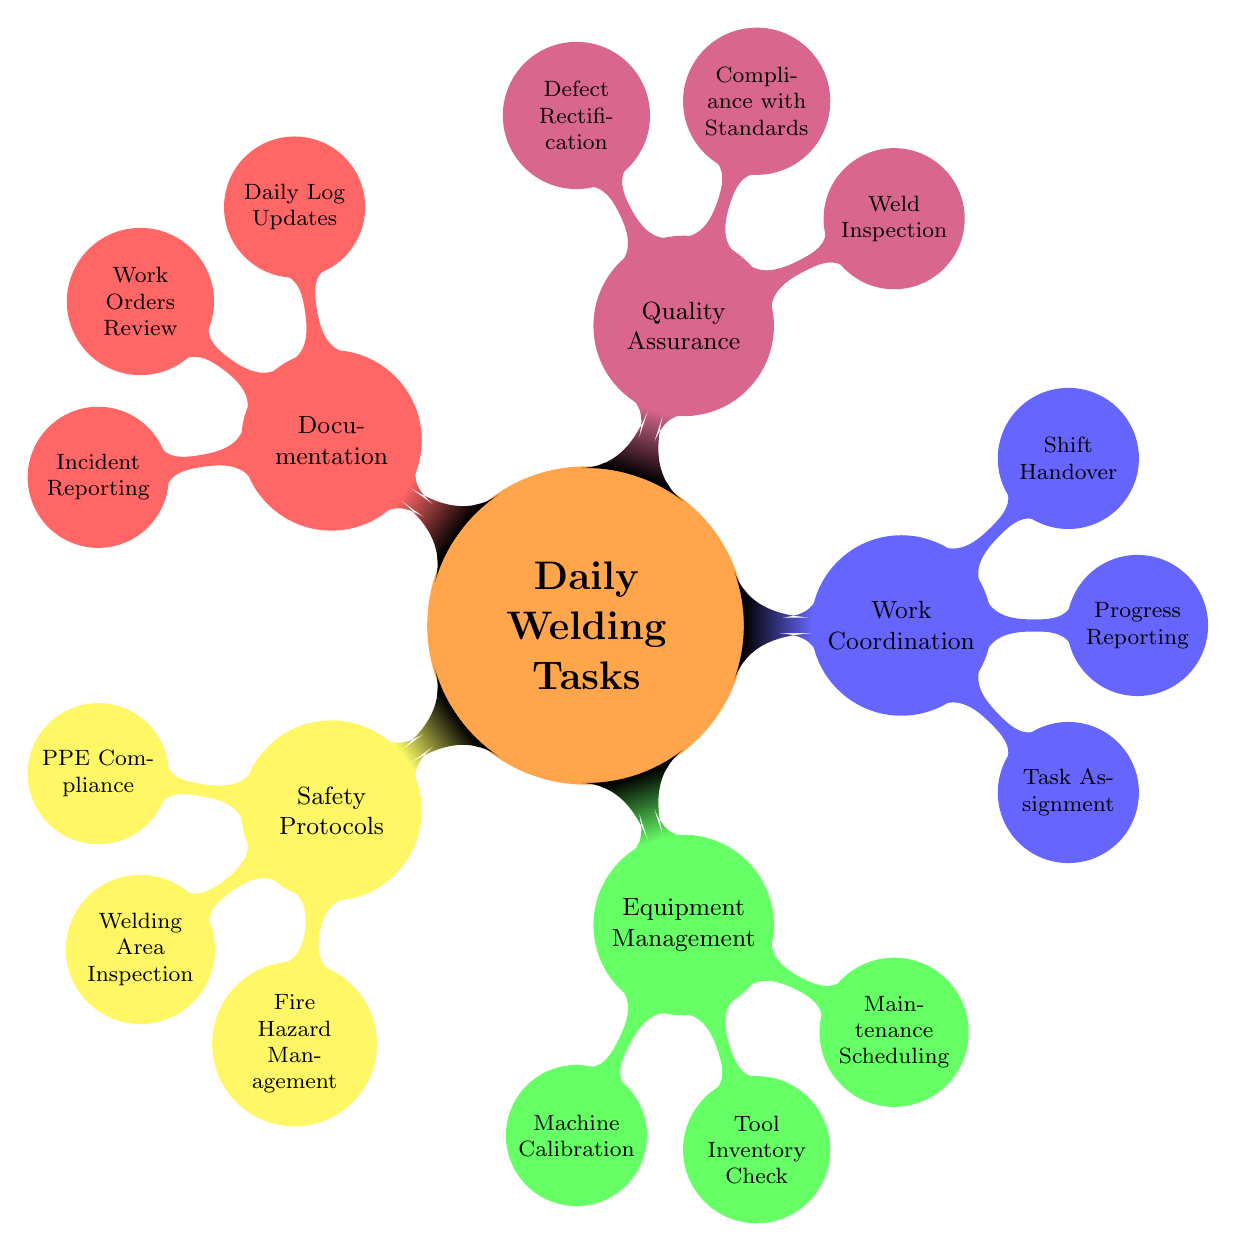What are the three main categories of daily welding tasks? The mind map displays five categories: Safety Protocols, Equipment Management, Work Coordination, Quality Assurance, and Documentation. Among these, the question specifies the three main categories, which are not stated but can be used as a general reference.
Answer: Safety Protocols, Equipment Management, Work Coordination How many nodes are there under Quality Assurance? In the "Quality Assurance" section, the mind map lists three specific nodes: Weld Inspection, Compliance with Standards, and Defect Rectification. Counting these gives us the total.
Answer: 3 What is one responsibility under Equipment Management? Under the "Equipment Management" category, there are three responsibilities: Machine Calibration, Tool Inventory Check, and Maintenance Scheduling. Any of these can be used as an answer.
Answer: Machine Calibration Which category directly relates to fire safety? The category concerned with fire safety is "Safety Protocols." Within this category, one specific responsibility is "Fire Hazard Management," demonstrating its direct relevance to fire safety.
Answer: Safety Protocols What type of documentation is mentioned for daily updates? The term "Daily Log Updates" is specifically mentioned within the "Documentation" category. This indicates a type of documentation required for daily tasks.
Answer: Daily Log Updates Which task involves communication during shift changes? "Shift Handover" is the task that involves communication during transition phases between shifts, reflecting the coordination required for effective on-site management.
Answer: Shift Handover What is the primary focus of the Quality Assurance category? The main focus of the "Quality Assurance" category is to ensure that welding tasks meet standards and are inspected correctly, which can be inferred from the listed tasks of Weld Inspection, Compliance with Standards, and Defect Rectification.
Answer: Compliance with Standards 